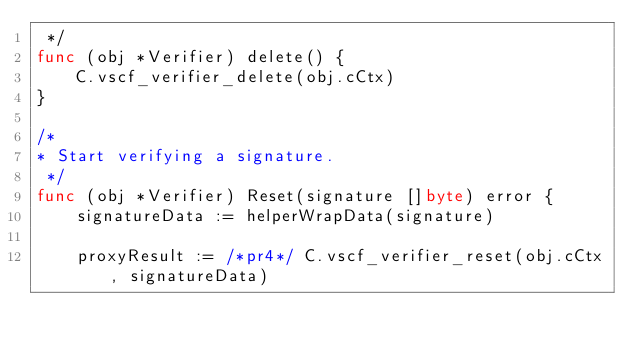<code> <loc_0><loc_0><loc_500><loc_500><_Go_> */
func (obj *Verifier) delete() {
	C.vscf_verifier_delete(obj.cCtx)
}

/*
* Start verifying a signature.
 */
func (obj *Verifier) Reset(signature []byte) error {
	signatureData := helperWrapData(signature)

	proxyResult := /*pr4*/ C.vscf_verifier_reset(obj.cCtx, signatureData)
</code> 